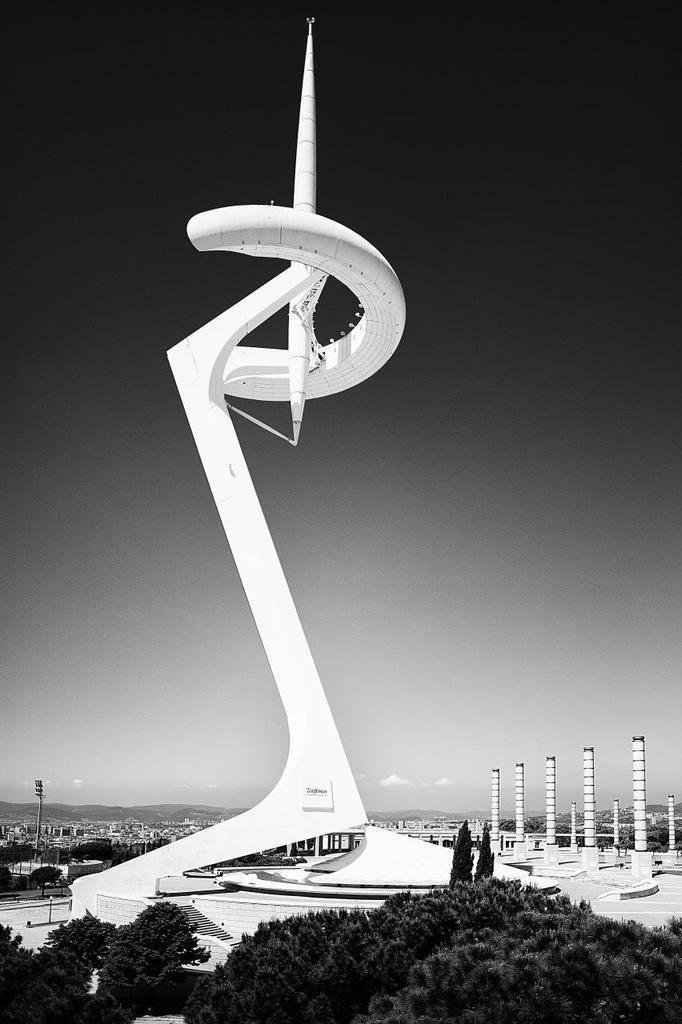Could you give a brief overview of what you see in this image? In this image I can see a architecture building and few trees. I can also see this image is black and white in colour. 